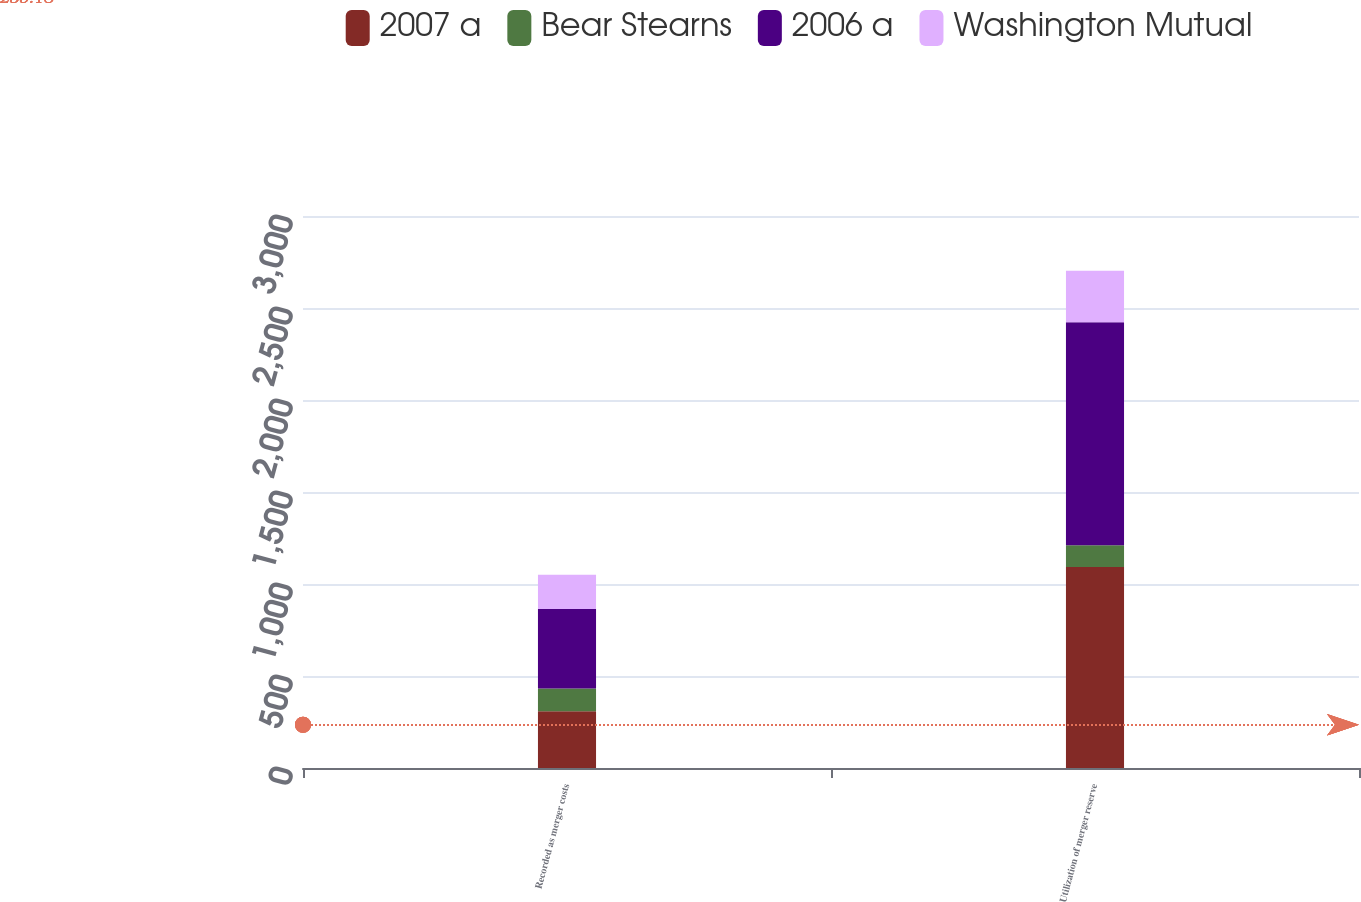Convert chart to OTSL. <chart><loc_0><loc_0><loc_500><loc_500><stacked_bar_chart><ecel><fcel>Recorded as merger costs<fcel>Utilization of merger reserve<nl><fcel>2007 a<fcel>308<fcel>1093<nl><fcel>Bear Stearns<fcel>124<fcel>118<nl><fcel>2006 a<fcel>432<fcel>1211<nl><fcel>Washington Mutual<fcel>186<fcel>281<nl></chart> 